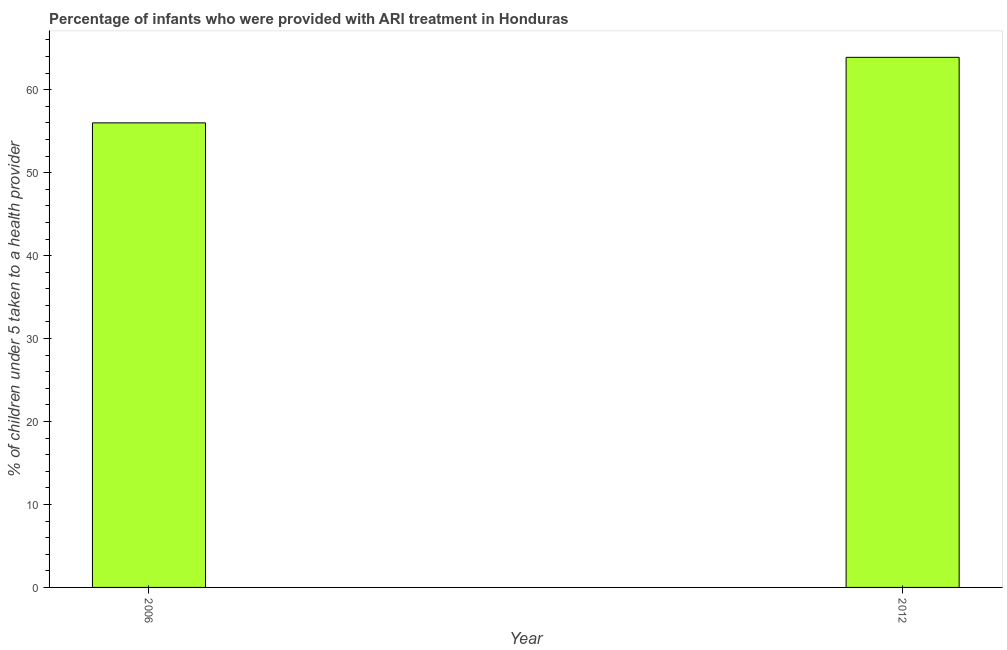What is the title of the graph?
Your answer should be very brief. Percentage of infants who were provided with ARI treatment in Honduras. What is the label or title of the Y-axis?
Provide a succinct answer. % of children under 5 taken to a health provider. What is the percentage of children who were provided with ari treatment in 2006?
Provide a short and direct response. 56. Across all years, what is the maximum percentage of children who were provided with ari treatment?
Offer a terse response. 63.9. In which year was the percentage of children who were provided with ari treatment minimum?
Provide a short and direct response. 2006. What is the sum of the percentage of children who were provided with ari treatment?
Provide a succinct answer. 119.9. What is the average percentage of children who were provided with ari treatment per year?
Give a very brief answer. 59.95. What is the median percentage of children who were provided with ari treatment?
Offer a terse response. 59.95. Do a majority of the years between 2006 and 2012 (inclusive) have percentage of children who were provided with ari treatment greater than 10 %?
Offer a very short reply. Yes. What is the ratio of the percentage of children who were provided with ari treatment in 2006 to that in 2012?
Ensure brevity in your answer.  0.88. Are all the bars in the graph horizontal?
Give a very brief answer. No. How many years are there in the graph?
Your answer should be very brief. 2. Are the values on the major ticks of Y-axis written in scientific E-notation?
Give a very brief answer. No. What is the % of children under 5 taken to a health provider of 2006?
Your answer should be compact. 56. What is the % of children under 5 taken to a health provider of 2012?
Offer a terse response. 63.9. What is the difference between the % of children under 5 taken to a health provider in 2006 and 2012?
Provide a short and direct response. -7.9. What is the ratio of the % of children under 5 taken to a health provider in 2006 to that in 2012?
Offer a very short reply. 0.88. 